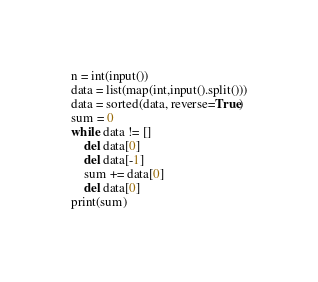<code> <loc_0><loc_0><loc_500><loc_500><_Python_>n = int(input())
data = list(map(int,input().split()))
data = sorted(data, reverse=True)
sum = 0
while data != []
    del data[0]
    del data[-1]
    sum += data[0]
    del data[0]
print(sum)</code> 